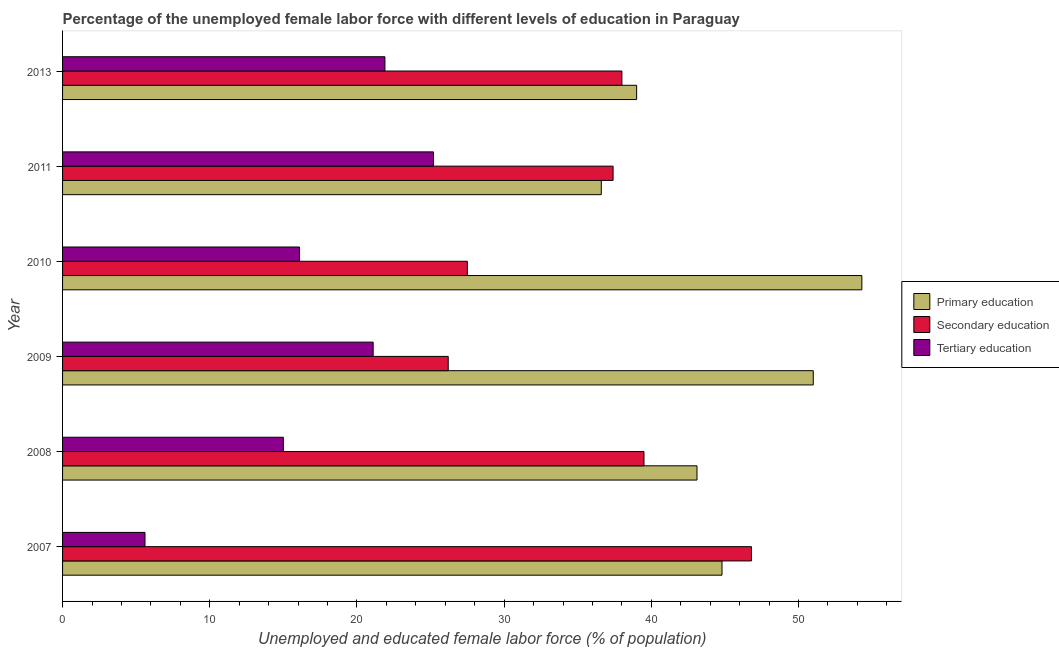How many groups of bars are there?
Offer a very short reply. 6. Are the number of bars on each tick of the Y-axis equal?
Offer a very short reply. Yes. How many bars are there on the 1st tick from the bottom?
Your answer should be compact. 3. In how many cases, is the number of bars for a given year not equal to the number of legend labels?
Your answer should be compact. 0. What is the percentage of female labor force who received secondary education in 2010?
Ensure brevity in your answer.  27.5. Across all years, what is the maximum percentage of female labor force who received primary education?
Provide a short and direct response. 54.3. Across all years, what is the minimum percentage of female labor force who received tertiary education?
Your response must be concise. 5.6. In which year was the percentage of female labor force who received tertiary education minimum?
Keep it short and to the point. 2007. What is the total percentage of female labor force who received tertiary education in the graph?
Offer a terse response. 104.9. What is the difference between the percentage of female labor force who received tertiary education in 2007 and that in 2013?
Offer a terse response. -16.3. What is the difference between the percentage of female labor force who received secondary education in 2009 and the percentage of female labor force who received primary education in 2013?
Make the answer very short. -12.8. What is the average percentage of female labor force who received primary education per year?
Provide a succinct answer. 44.8. In the year 2007, what is the difference between the percentage of female labor force who received secondary education and percentage of female labor force who received tertiary education?
Ensure brevity in your answer.  41.2. In how many years, is the percentage of female labor force who received tertiary education greater than 52 %?
Offer a terse response. 0. What is the ratio of the percentage of female labor force who received tertiary education in 2009 to that in 2013?
Give a very brief answer. 0.96. Is the percentage of female labor force who received tertiary education in 2011 less than that in 2013?
Offer a very short reply. No. Is the difference between the percentage of female labor force who received secondary education in 2011 and 2013 greater than the difference between the percentage of female labor force who received primary education in 2011 and 2013?
Ensure brevity in your answer.  Yes. What is the difference between the highest and the second highest percentage of female labor force who received secondary education?
Offer a very short reply. 7.3. What is the difference between the highest and the lowest percentage of female labor force who received secondary education?
Ensure brevity in your answer.  20.6. What does the 3rd bar from the top in 2010 represents?
Ensure brevity in your answer.  Primary education. What does the 3rd bar from the bottom in 2007 represents?
Offer a terse response. Tertiary education. Are all the bars in the graph horizontal?
Give a very brief answer. Yes. How many years are there in the graph?
Make the answer very short. 6. Are the values on the major ticks of X-axis written in scientific E-notation?
Your answer should be very brief. No. How many legend labels are there?
Provide a short and direct response. 3. What is the title of the graph?
Your answer should be compact. Percentage of the unemployed female labor force with different levels of education in Paraguay. Does "Consumption Tax" appear as one of the legend labels in the graph?
Offer a terse response. No. What is the label or title of the X-axis?
Offer a terse response. Unemployed and educated female labor force (% of population). What is the label or title of the Y-axis?
Provide a short and direct response. Year. What is the Unemployed and educated female labor force (% of population) in Primary education in 2007?
Offer a terse response. 44.8. What is the Unemployed and educated female labor force (% of population) of Secondary education in 2007?
Your response must be concise. 46.8. What is the Unemployed and educated female labor force (% of population) of Tertiary education in 2007?
Your answer should be compact. 5.6. What is the Unemployed and educated female labor force (% of population) of Primary education in 2008?
Keep it short and to the point. 43.1. What is the Unemployed and educated female labor force (% of population) of Secondary education in 2008?
Give a very brief answer. 39.5. What is the Unemployed and educated female labor force (% of population) in Primary education in 2009?
Keep it short and to the point. 51. What is the Unemployed and educated female labor force (% of population) of Secondary education in 2009?
Your response must be concise. 26.2. What is the Unemployed and educated female labor force (% of population) of Tertiary education in 2009?
Your answer should be very brief. 21.1. What is the Unemployed and educated female labor force (% of population) of Primary education in 2010?
Give a very brief answer. 54.3. What is the Unemployed and educated female labor force (% of population) in Tertiary education in 2010?
Offer a terse response. 16.1. What is the Unemployed and educated female labor force (% of population) in Primary education in 2011?
Your answer should be compact. 36.6. What is the Unemployed and educated female labor force (% of population) in Secondary education in 2011?
Provide a short and direct response. 37.4. What is the Unemployed and educated female labor force (% of population) of Tertiary education in 2011?
Ensure brevity in your answer.  25.2. What is the Unemployed and educated female labor force (% of population) in Primary education in 2013?
Provide a short and direct response. 39. What is the Unemployed and educated female labor force (% of population) in Tertiary education in 2013?
Offer a very short reply. 21.9. Across all years, what is the maximum Unemployed and educated female labor force (% of population) in Primary education?
Provide a succinct answer. 54.3. Across all years, what is the maximum Unemployed and educated female labor force (% of population) in Secondary education?
Ensure brevity in your answer.  46.8. Across all years, what is the maximum Unemployed and educated female labor force (% of population) in Tertiary education?
Provide a succinct answer. 25.2. Across all years, what is the minimum Unemployed and educated female labor force (% of population) of Primary education?
Offer a very short reply. 36.6. Across all years, what is the minimum Unemployed and educated female labor force (% of population) in Secondary education?
Provide a succinct answer. 26.2. Across all years, what is the minimum Unemployed and educated female labor force (% of population) in Tertiary education?
Provide a succinct answer. 5.6. What is the total Unemployed and educated female labor force (% of population) of Primary education in the graph?
Offer a very short reply. 268.8. What is the total Unemployed and educated female labor force (% of population) in Secondary education in the graph?
Provide a succinct answer. 215.4. What is the total Unemployed and educated female labor force (% of population) of Tertiary education in the graph?
Keep it short and to the point. 104.9. What is the difference between the Unemployed and educated female labor force (% of population) in Secondary education in 2007 and that in 2008?
Offer a very short reply. 7.3. What is the difference between the Unemployed and educated female labor force (% of population) in Tertiary education in 2007 and that in 2008?
Your answer should be compact. -9.4. What is the difference between the Unemployed and educated female labor force (% of population) in Primary education in 2007 and that in 2009?
Your answer should be compact. -6.2. What is the difference between the Unemployed and educated female labor force (% of population) of Secondary education in 2007 and that in 2009?
Your answer should be compact. 20.6. What is the difference between the Unemployed and educated female labor force (% of population) of Tertiary education in 2007 and that in 2009?
Make the answer very short. -15.5. What is the difference between the Unemployed and educated female labor force (% of population) of Primary education in 2007 and that in 2010?
Your answer should be compact. -9.5. What is the difference between the Unemployed and educated female labor force (% of population) of Secondary education in 2007 and that in 2010?
Make the answer very short. 19.3. What is the difference between the Unemployed and educated female labor force (% of population) in Primary education in 2007 and that in 2011?
Your answer should be very brief. 8.2. What is the difference between the Unemployed and educated female labor force (% of population) in Secondary education in 2007 and that in 2011?
Your answer should be very brief. 9.4. What is the difference between the Unemployed and educated female labor force (% of population) of Tertiary education in 2007 and that in 2011?
Make the answer very short. -19.6. What is the difference between the Unemployed and educated female labor force (% of population) of Primary education in 2007 and that in 2013?
Your answer should be very brief. 5.8. What is the difference between the Unemployed and educated female labor force (% of population) of Secondary education in 2007 and that in 2013?
Your answer should be compact. 8.8. What is the difference between the Unemployed and educated female labor force (% of population) of Tertiary education in 2007 and that in 2013?
Give a very brief answer. -16.3. What is the difference between the Unemployed and educated female labor force (% of population) in Tertiary education in 2008 and that in 2009?
Give a very brief answer. -6.1. What is the difference between the Unemployed and educated female labor force (% of population) in Primary education in 2008 and that in 2010?
Your answer should be compact. -11.2. What is the difference between the Unemployed and educated female labor force (% of population) of Secondary education in 2008 and that in 2011?
Ensure brevity in your answer.  2.1. What is the difference between the Unemployed and educated female labor force (% of population) in Tertiary education in 2008 and that in 2011?
Provide a succinct answer. -10.2. What is the difference between the Unemployed and educated female labor force (% of population) in Secondary education in 2008 and that in 2013?
Keep it short and to the point. 1.5. What is the difference between the Unemployed and educated female labor force (% of population) in Tertiary education in 2008 and that in 2013?
Your answer should be compact. -6.9. What is the difference between the Unemployed and educated female labor force (% of population) in Primary education in 2009 and that in 2011?
Your answer should be very brief. 14.4. What is the difference between the Unemployed and educated female labor force (% of population) of Secondary education in 2009 and that in 2011?
Your answer should be compact. -11.2. What is the difference between the Unemployed and educated female labor force (% of population) of Primary education in 2009 and that in 2013?
Ensure brevity in your answer.  12. What is the difference between the Unemployed and educated female labor force (% of population) in Secondary education in 2009 and that in 2013?
Your answer should be very brief. -11.8. What is the difference between the Unemployed and educated female labor force (% of population) of Tertiary education in 2009 and that in 2013?
Offer a very short reply. -0.8. What is the difference between the Unemployed and educated female labor force (% of population) of Primary education in 2010 and that in 2013?
Provide a succinct answer. 15.3. What is the difference between the Unemployed and educated female labor force (% of population) of Primary education in 2011 and that in 2013?
Offer a very short reply. -2.4. What is the difference between the Unemployed and educated female labor force (% of population) in Secondary education in 2011 and that in 2013?
Provide a short and direct response. -0.6. What is the difference between the Unemployed and educated female labor force (% of population) in Tertiary education in 2011 and that in 2013?
Give a very brief answer. 3.3. What is the difference between the Unemployed and educated female labor force (% of population) of Primary education in 2007 and the Unemployed and educated female labor force (% of population) of Secondary education in 2008?
Offer a very short reply. 5.3. What is the difference between the Unemployed and educated female labor force (% of population) in Primary education in 2007 and the Unemployed and educated female labor force (% of population) in Tertiary education in 2008?
Keep it short and to the point. 29.8. What is the difference between the Unemployed and educated female labor force (% of population) of Secondary education in 2007 and the Unemployed and educated female labor force (% of population) of Tertiary education in 2008?
Ensure brevity in your answer.  31.8. What is the difference between the Unemployed and educated female labor force (% of population) in Primary education in 2007 and the Unemployed and educated female labor force (% of population) in Tertiary education in 2009?
Make the answer very short. 23.7. What is the difference between the Unemployed and educated female labor force (% of population) in Secondary education in 2007 and the Unemployed and educated female labor force (% of population) in Tertiary education in 2009?
Ensure brevity in your answer.  25.7. What is the difference between the Unemployed and educated female labor force (% of population) in Primary education in 2007 and the Unemployed and educated female labor force (% of population) in Tertiary education in 2010?
Give a very brief answer. 28.7. What is the difference between the Unemployed and educated female labor force (% of population) in Secondary education in 2007 and the Unemployed and educated female labor force (% of population) in Tertiary education in 2010?
Provide a short and direct response. 30.7. What is the difference between the Unemployed and educated female labor force (% of population) of Primary education in 2007 and the Unemployed and educated female labor force (% of population) of Tertiary education in 2011?
Your response must be concise. 19.6. What is the difference between the Unemployed and educated female labor force (% of population) of Secondary education in 2007 and the Unemployed and educated female labor force (% of population) of Tertiary education in 2011?
Provide a short and direct response. 21.6. What is the difference between the Unemployed and educated female labor force (% of population) in Primary education in 2007 and the Unemployed and educated female labor force (% of population) in Secondary education in 2013?
Your answer should be very brief. 6.8. What is the difference between the Unemployed and educated female labor force (% of population) of Primary education in 2007 and the Unemployed and educated female labor force (% of population) of Tertiary education in 2013?
Offer a very short reply. 22.9. What is the difference between the Unemployed and educated female labor force (% of population) of Secondary education in 2007 and the Unemployed and educated female labor force (% of population) of Tertiary education in 2013?
Your answer should be compact. 24.9. What is the difference between the Unemployed and educated female labor force (% of population) in Primary education in 2008 and the Unemployed and educated female labor force (% of population) in Tertiary education in 2009?
Ensure brevity in your answer.  22. What is the difference between the Unemployed and educated female labor force (% of population) in Primary education in 2008 and the Unemployed and educated female labor force (% of population) in Secondary education in 2010?
Offer a terse response. 15.6. What is the difference between the Unemployed and educated female labor force (% of population) in Secondary education in 2008 and the Unemployed and educated female labor force (% of population) in Tertiary education in 2010?
Make the answer very short. 23.4. What is the difference between the Unemployed and educated female labor force (% of population) of Primary education in 2008 and the Unemployed and educated female labor force (% of population) of Secondary education in 2011?
Ensure brevity in your answer.  5.7. What is the difference between the Unemployed and educated female labor force (% of population) of Primary education in 2008 and the Unemployed and educated female labor force (% of population) of Tertiary education in 2011?
Your answer should be very brief. 17.9. What is the difference between the Unemployed and educated female labor force (% of population) of Secondary education in 2008 and the Unemployed and educated female labor force (% of population) of Tertiary education in 2011?
Provide a succinct answer. 14.3. What is the difference between the Unemployed and educated female labor force (% of population) of Primary education in 2008 and the Unemployed and educated female labor force (% of population) of Tertiary education in 2013?
Offer a very short reply. 21.2. What is the difference between the Unemployed and educated female labor force (% of population) of Primary education in 2009 and the Unemployed and educated female labor force (% of population) of Secondary education in 2010?
Give a very brief answer. 23.5. What is the difference between the Unemployed and educated female labor force (% of population) in Primary education in 2009 and the Unemployed and educated female labor force (% of population) in Tertiary education in 2010?
Give a very brief answer. 34.9. What is the difference between the Unemployed and educated female labor force (% of population) in Primary education in 2009 and the Unemployed and educated female labor force (% of population) in Tertiary education in 2011?
Your answer should be very brief. 25.8. What is the difference between the Unemployed and educated female labor force (% of population) in Secondary education in 2009 and the Unemployed and educated female labor force (% of population) in Tertiary education in 2011?
Provide a succinct answer. 1. What is the difference between the Unemployed and educated female labor force (% of population) in Primary education in 2009 and the Unemployed and educated female labor force (% of population) in Secondary education in 2013?
Ensure brevity in your answer.  13. What is the difference between the Unemployed and educated female labor force (% of population) in Primary education in 2009 and the Unemployed and educated female labor force (% of population) in Tertiary education in 2013?
Keep it short and to the point. 29.1. What is the difference between the Unemployed and educated female labor force (% of population) of Secondary education in 2009 and the Unemployed and educated female labor force (% of population) of Tertiary education in 2013?
Make the answer very short. 4.3. What is the difference between the Unemployed and educated female labor force (% of population) in Primary education in 2010 and the Unemployed and educated female labor force (% of population) in Tertiary education in 2011?
Keep it short and to the point. 29.1. What is the difference between the Unemployed and educated female labor force (% of population) in Primary education in 2010 and the Unemployed and educated female labor force (% of population) in Secondary education in 2013?
Your answer should be compact. 16.3. What is the difference between the Unemployed and educated female labor force (% of population) of Primary education in 2010 and the Unemployed and educated female labor force (% of population) of Tertiary education in 2013?
Your answer should be very brief. 32.4. What is the difference between the Unemployed and educated female labor force (% of population) in Secondary education in 2010 and the Unemployed and educated female labor force (% of population) in Tertiary education in 2013?
Provide a short and direct response. 5.6. What is the difference between the Unemployed and educated female labor force (% of population) of Primary education in 2011 and the Unemployed and educated female labor force (% of population) of Tertiary education in 2013?
Keep it short and to the point. 14.7. What is the average Unemployed and educated female labor force (% of population) in Primary education per year?
Keep it short and to the point. 44.8. What is the average Unemployed and educated female labor force (% of population) in Secondary education per year?
Offer a terse response. 35.9. What is the average Unemployed and educated female labor force (% of population) of Tertiary education per year?
Offer a terse response. 17.48. In the year 2007, what is the difference between the Unemployed and educated female labor force (% of population) of Primary education and Unemployed and educated female labor force (% of population) of Tertiary education?
Your answer should be compact. 39.2. In the year 2007, what is the difference between the Unemployed and educated female labor force (% of population) in Secondary education and Unemployed and educated female labor force (% of population) in Tertiary education?
Offer a terse response. 41.2. In the year 2008, what is the difference between the Unemployed and educated female labor force (% of population) in Primary education and Unemployed and educated female labor force (% of population) in Tertiary education?
Keep it short and to the point. 28.1. In the year 2009, what is the difference between the Unemployed and educated female labor force (% of population) of Primary education and Unemployed and educated female labor force (% of population) of Secondary education?
Offer a terse response. 24.8. In the year 2009, what is the difference between the Unemployed and educated female labor force (% of population) of Primary education and Unemployed and educated female labor force (% of population) of Tertiary education?
Give a very brief answer. 29.9. In the year 2009, what is the difference between the Unemployed and educated female labor force (% of population) of Secondary education and Unemployed and educated female labor force (% of population) of Tertiary education?
Offer a terse response. 5.1. In the year 2010, what is the difference between the Unemployed and educated female labor force (% of population) of Primary education and Unemployed and educated female labor force (% of population) of Secondary education?
Your answer should be very brief. 26.8. In the year 2010, what is the difference between the Unemployed and educated female labor force (% of population) of Primary education and Unemployed and educated female labor force (% of population) of Tertiary education?
Offer a terse response. 38.2. In the year 2010, what is the difference between the Unemployed and educated female labor force (% of population) of Secondary education and Unemployed and educated female labor force (% of population) of Tertiary education?
Your answer should be very brief. 11.4. In the year 2011, what is the difference between the Unemployed and educated female labor force (% of population) of Primary education and Unemployed and educated female labor force (% of population) of Secondary education?
Offer a very short reply. -0.8. In the year 2011, what is the difference between the Unemployed and educated female labor force (% of population) of Primary education and Unemployed and educated female labor force (% of population) of Tertiary education?
Offer a terse response. 11.4. In the year 2013, what is the difference between the Unemployed and educated female labor force (% of population) in Primary education and Unemployed and educated female labor force (% of population) in Tertiary education?
Offer a terse response. 17.1. What is the ratio of the Unemployed and educated female labor force (% of population) in Primary education in 2007 to that in 2008?
Provide a succinct answer. 1.04. What is the ratio of the Unemployed and educated female labor force (% of population) in Secondary education in 2007 to that in 2008?
Provide a short and direct response. 1.18. What is the ratio of the Unemployed and educated female labor force (% of population) of Tertiary education in 2007 to that in 2008?
Your response must be concise. 0.37. What is the ratio of the Unemployed and educated female labor force (% of population) in Primary education in 2007 to that in 2009?
Offer a terse response. 0.88. What is the ratio of the Unemployed and educated female labor force (% of population) of Secondary education in 2007 to that in 2009?
Provide a succinct answer. 1.79. What is the ratio of the Unemployed and educated female labor force (% of population) in Tertiary education in 2007 to that in 2009?
Your response must be concise. 0.27. What is the ratio of the Unemployed and educated female labor force (% of population) of Primary education in 2007 to that in 2010?
Ensure brevity in your answer.  0.82. What is the ratio of the Unemployed and educated female labor force (% of population) in Secondary education in 2007 to that in 2010?
Give a very brief answer. 1.7. What is the ratio of the Unemployed and educated female labor force (% of population) in Tertiary education in 2007 to that in 2010?
Your answer should be very brief. 0.35. What is the ratio of the Unemployed and educated female labor force (% of population) of Primary education in 2007 to that in 2011?
Your answer should be compact. 1.22. What is the ratio of the Unemployed and educated female labor force (% of population) of Secondary education in 2007 to that in 2011?
Offer a terse response. 1.25. What is the ratio of the Unemployed and educated female labor force (% of population) of Tertiary education in 2007 to that in 2011?
Provide a succinct answer. 0.22. What is the ratio of the Unemployed and educated female labor force (% of population) of Primary education in 2007 to that in 2013?
Your response must be concise. 1.15. What is the ratio of the Unemployed and educated female labor force (% of population) in Secondary education in 2007 to that in 2013?
Offer a terse response. 1.23. What is the ratio of the Unemployed and educated female labor force (% of population) of Tertiary education in 2007 to that in 2013?
Ensure brevity in your answer.  0.26. What is the ratio of the Unemployed and educated female labor force (% of population) of Primary education in 2008 to that in 2009?
Provide a short and direct response. 0.85. What is the ratio of the Unemployed and educated female labor force (% of population) in Secondary education in 2008 to that in 2009?
Your answer should be compact. 1.51. What is the ratio of the Unemployed and educated female labor force (% of population) of Tertiary education in 2008 to that in 2009?
Offer a terse response. 0.71. What is the ratio of the Unemployed and educated female labor force (% of population) in Primary education in 2008 to that in 2010?
Provide a succinct answer. 0.79. What is the ratio of the Unemployed and educated female labor force (% of population) in Secondary education in 2008 to that in 2010?
Make the answer very short. 1.44. What is the ratio of the Unemployed and educated female labor force (% of population) in Tertiary education in 2008 to that in 2010?
Keep it short and to the point. 0.93. What is the ratio of the Unemployed and educated female labor force (% of population) in Primary education in 2008 to that in 2011?
Provide a short and direct response. 1.18. What is the ratio of the Unemployed and educated female labor force (% of population) of Secondary education in 2008 to that in 2011?
Offer a very short reply. 1.06. What is the ratio of the Unemployed and educated female labor force (% of population) of Tertiary education in 2008 to that in 2011?
Your answer should be very brief. 0.6. What is the ratio of the Unemployed and educated female labor force (% of population) in Primary education in 2008 to that in 2013?
Offer a terse response. 1.11. What is the ratio of the Unemployed and educated female labor force (% of population) in Secondary education in 2008 to that in 2013?
Provide a short and direct response. 1.04. What is the ratio of the Unemployed and educated female labor force (% of population) in Tertiary education in 2008 to that in 2013?
Your answer should be compact. 0.68. What is the ratio of the Unemployed and educated female labor force (% of population) in Primary education in 2009 to that in 2010?
Offer a terse response. 0.94. What is the ratio of the Unemployed and educated female labor force (% of population) in Secondary education in 2009 to that in 2010?
Your answer should be compact. 0.95. What is the ratio of the Unemployed and educated female labor force (% of population) in Tertiary education in 2009 to that in 2010?
Offer a very short reply. 1.31. What is the ratio of the Unemployed and educated female labor force (% of population) in Primary education in 2009 to that in 2011?
Provide a short and direct response. 1.39. What is the ratio of the Unemployed and educated female labor force (% of population) in Secondary education in 2009 to that in 2011?
Make the answer very short. 0.7. What is the ratio of the Unemployed and educated female labor force (% of population) in Tertiary education in 2009 to that in 2011?
Make the answer very short. 0.84. What is the ratio of the Unemployed and educated female labor force (% of population) in Primary education in 2009 to that in 2013?
Your answer should be compact. 1.31. What is the ratio of the Unemployed and educated female labor force (% of population) in Secondary education in 2009 to that in 2013?
Keep it short and to the point. 0.69. What is the ratio of the Unemployed and educated female labor force (% of population) of Tertiary education in 2009 to that in 2013?
Provide a succinct answer. 0.96. What is the ratio of the Unemployed and educated female labor force (% of population) in Primary education in 2010 to that in 2011?
Your response must be concise. 1.48. What is the ratio of the Unemployed and educated female labor force (% of population) of Secondary education in 2010 to that in 2011?
Ensure brevity in your answer.  0.74. What is the ratio of the Unemployed and educated female labor force (% of population) in Tertiary education in 2010 to that in 2011?
Your response must be concise. 0.64. What is the ratio of the Unemployed and educated female labor force (% of population) in Primary education in 2010 to that in 2013?
Provide a short and direct response. 1.39. What is the ratio of the Unemployed and educated female labor force (% of population) of Secondary education in 2010 to that in 2013?
Make the answer very short. 0.72. What is the ratio of the Unemployed and educated female labor force (% of population) of Tertiary education in 2010 to that in 2013?
Your response must be concise. 0.74. What is the ratio of the Unemployed and educated female labor force (% of population) of Primary education in 2011 to that in 2013?
Give a very brief answer. 0.94. What is the ratio of the Unemployed and educated female labor force (% of population) in Secondary education in 2011 to that in 2013?
Your answer should be very brief. 0.98. What is the ratio of the Unemployed and educated female labor force (% of population) in Tertiary education in 2011 to that in 2013?
Ensure brevity in your answer.  1.15. What is the difference between the highest and the second highest Unemployed and educated female labor force (% of population) in Primary education?
Your answer should be very brief. 3.3. What is the difference between the highest and the second highest Unemployed and educated female labor force (% of population) of Secondary education?
Offer a terse response. 7.3. What is the difference between the highest and the lowest Unemployed and educated female labor force (% of population) of Primary education?
Your answer should be very brief. 17.7. What is the difference between the highest and the lowest Unemployed and educated female labor force (% of population) in Secondary education?
Offer a terse response. 20.6. What is the difference between the highest and the lowest Unemployed and educated female labor force (% of population) of Tertiary education?
Offer a very short reply. 19.6. 